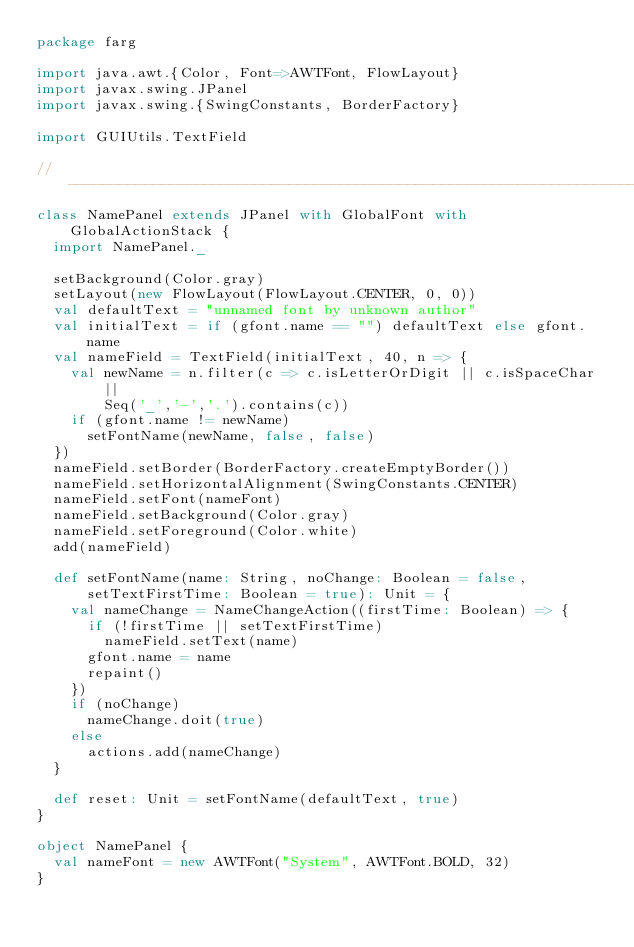Convert code to text. <code><loc_0><loc_0><loc_500><loc_500><_Scala_>package farg

import java.awt.{Color, Font=>AWTFont, FlowLayout}
import javax.swing.JPanel
import javax.swing.{SwingConstants, BorderFactory}

import GUIUtils.TextField

// ----------------------------------------------------------------------------
class NamePanel extends JPanel with GlobalFont with GlobalActionStack {
  import NamePanel._

  setBackground(Color.gray)
  setLayout(new FlowLayout(FlowLayout.CENTER, 0, 0))
  val defaultText = "unnamed font by unknown author"
  val initialText = if (gfont.name == "") defaultText else gfont.name
  val nameField = TextField(initialText, 40, n => {
    val newName = n.filter(c => c.isLetterOrDigit || c.isSpaceChar || 
        Seq('_','-','.').contains(c))
    if (gfont.name != newName)
      setFontName(newName, false, false)
  })
  nameField.setBorder(BorderFactory.createEmptyBorder())
  nameField.setHorizontalAlignment(SwingConstants.CENTER)
  nameField.setFont(nameFont)
  nameField.setBackground(Color.gray)
  nameField.setForeground(Color.white)
  add(nameField)

  def setFontName(name: String, noChange: Boolean = false, 
      setTextFirstTime: Boolean = true): Unit = {
    val nameChange = NameChangeAction((firstTime: Boolean) => {
      if (!firstTime || setTextFirstTime)
        nameField.setText(name)
      gfont.name = name
      repaint()
    })
    if (noChange)
      nameChange.doit(true)
    else
      actions.add(nameChange)
  }

  def reset: Unit = setFontName(defaultText, true)
}

object NamePanel {
  val nameFont = new AWTFont("System", AWTFont.BOLD, 32)
}
</code> 